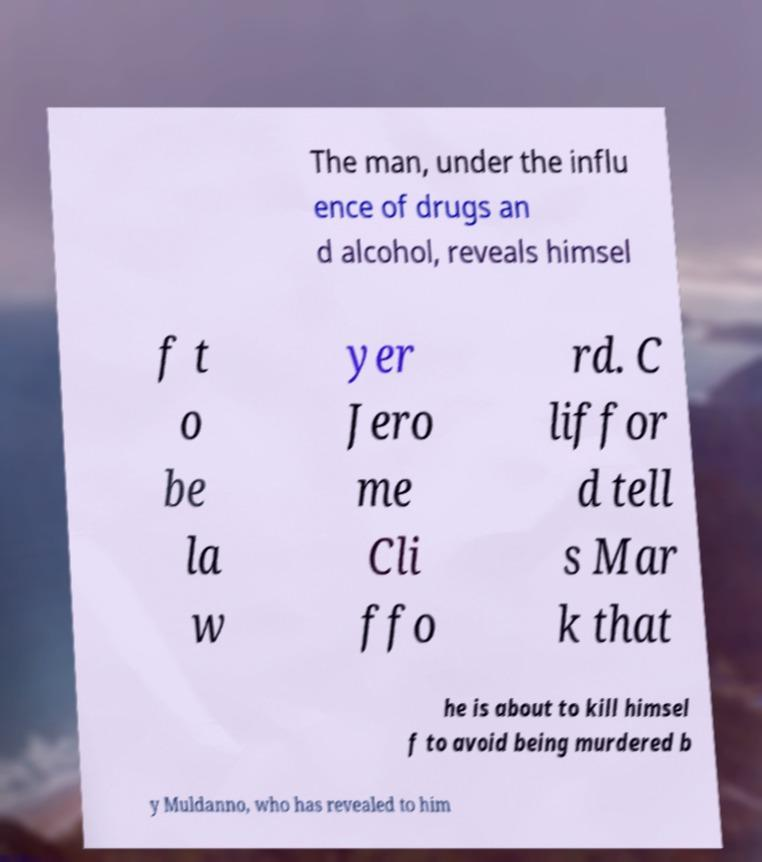Could you extract and type out the text from this image? The man, under the influ ence of drugs an d alcohol, reveals himsel f t o be la w yer Jero me Cli ffo rd. C liffor d tell s Mar k that he is about to kill himsel f to avoid being murdered b y Muldanno, who has revealed to him 